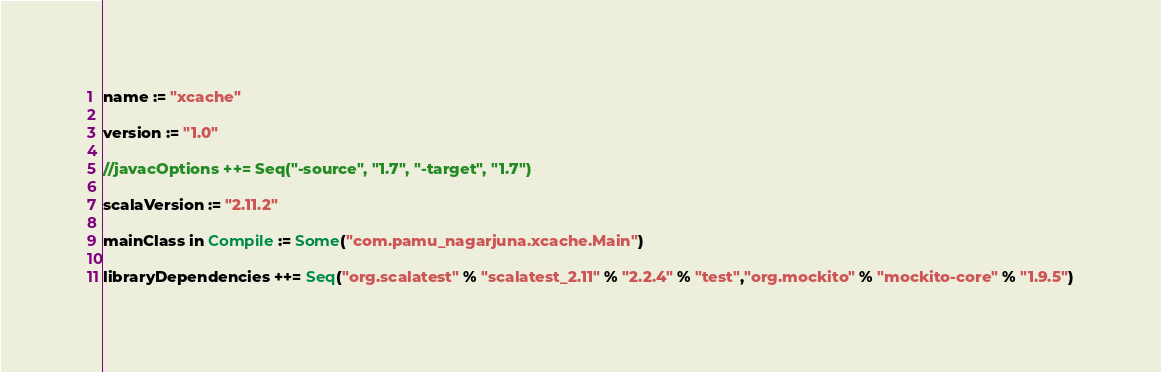Convert code to text. <code><loc_0><loc_0><loc_500><loc_500><_Scala_>name := "xcache"

version := "1.0"

//javacOptions ++= Seq("-source", "1.7", "-target", "1.7")

scalaVersion := "2.11.2"

mainClass in Compile := Some("com.pamu_nagarjuna.xcache.Main")

libraryDependencies ++= Seq("org.scalatest" % "scalatest_2.11" % "2.2.4" % "test","org.mockito" % "mockito-core" % "1.9.5")</code> 